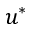Convert formula to latex. <formula><loc_0><loc_0><loc_500><loc_500>u ^ { * }</formula> 